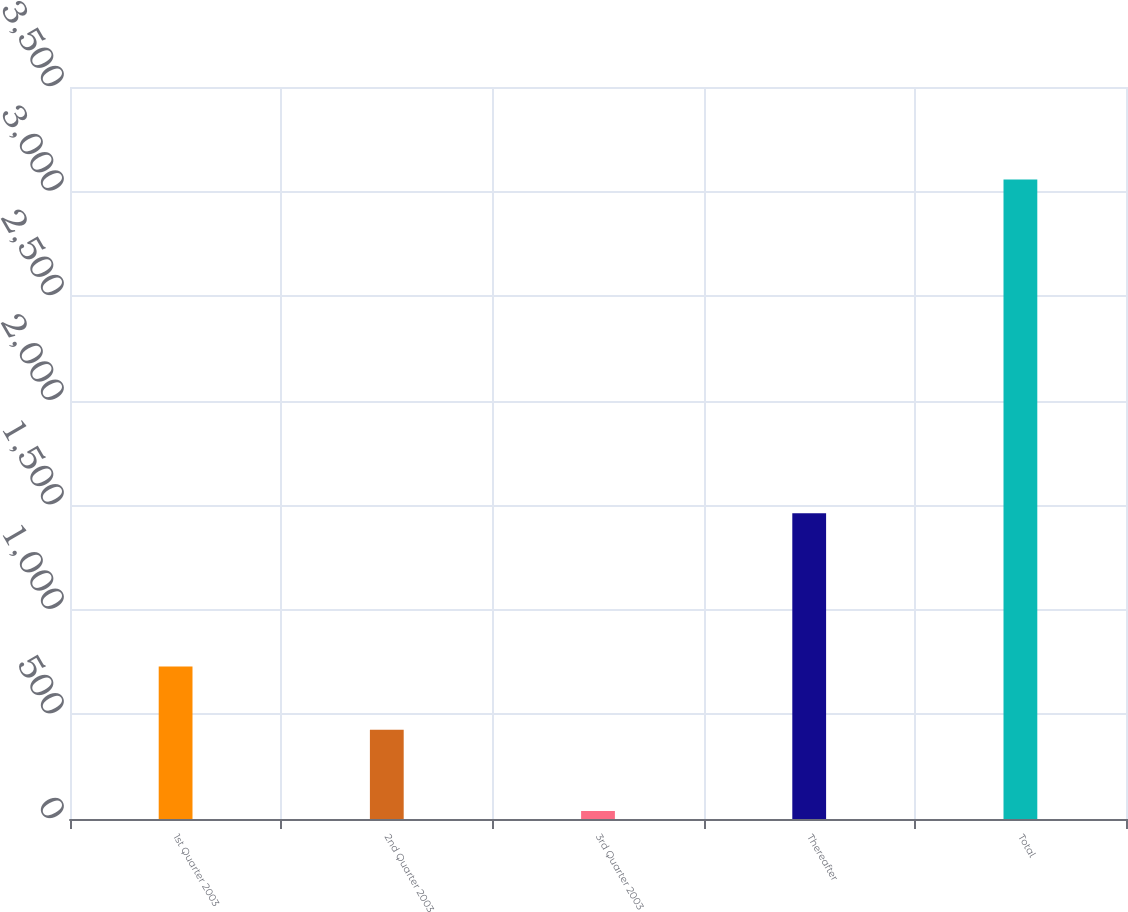Convert chart. <chart><loc_0><loc_0><loc_500><loc_500><bar_chart><fcel>1st Quarter 2003<fcel>2nd Quarter 2003<fcel>3rd Quarter 2003<fcel>Thereafter<fcel>Total<nl><fcel>729<fcel>427<fcel>38<fcel>1462<fcel>3058<nl></chart> 